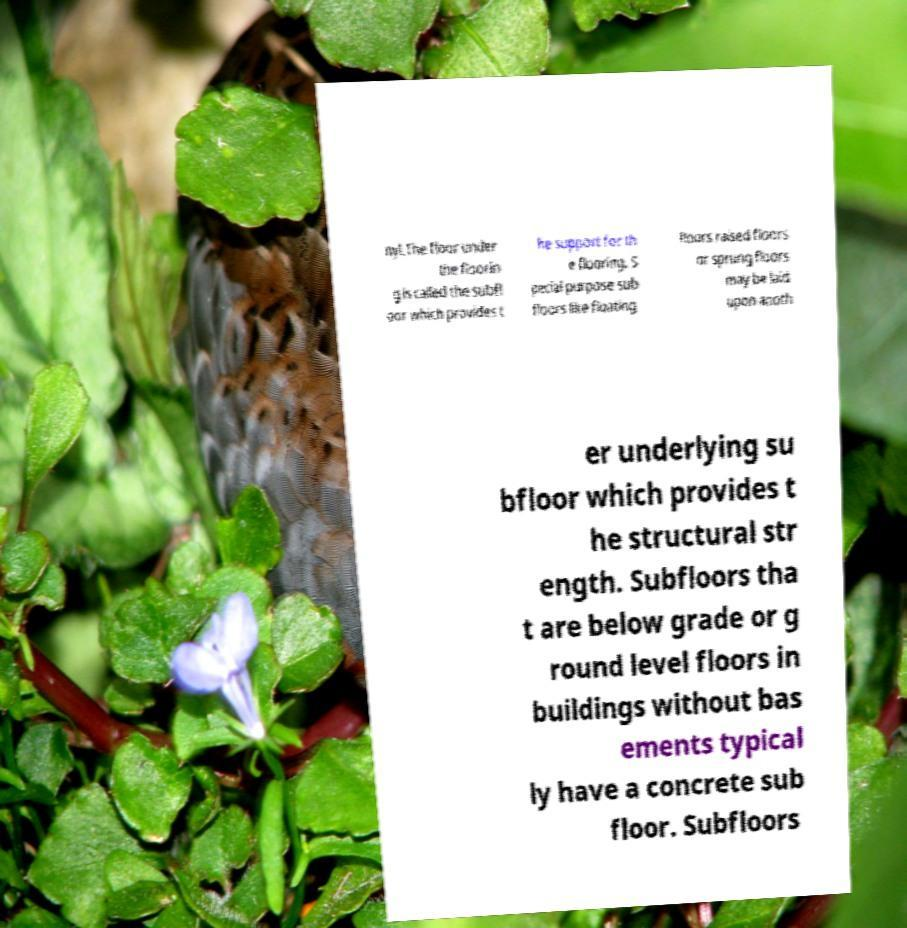Could you extract and type out the text from this image? nyl.The floor under the floorin g is called the subfl oor which provides t he support for th e flooring. S pecial purpose sub floors like floating floors raised floors or sprung floors may be laid upon anoth er underlying su bfloor which provides t he structural str ength. Subfloors tha t are below grade or g round level floors in buildings without bas ements typical ly have a concrete sub floor. Subfloors 